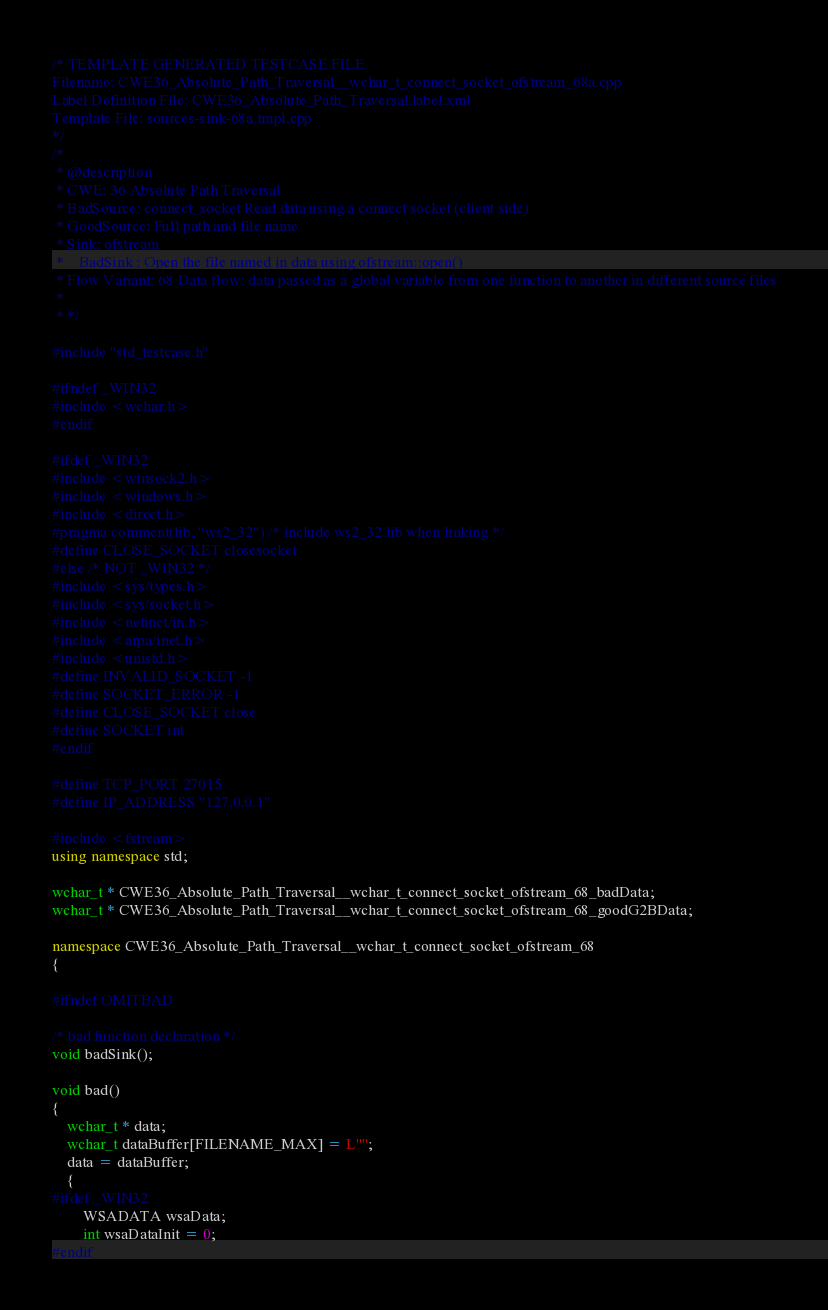Convert code to text. <code><loc_0><loc_0><loc_500><loc_500><_C++_>/* TEMPLATE GENERATED TESTCASE FILE
Filename: CWE36_Absolute_Path_Traversal__wchar_t_connect_socket_ofstream_68a.cpp
Label Definition File: CWE36_Absolute_Path_Traversal.label.xml
Template File: sources-sink-68a.tmpl.cpp
*/
/*
 * @description
 * CWE: 36 Absolute Path Traversal
 * BadSource: connect_socket Read data using a connect socket (client side)
 * GoodSource: Full path and file name
 * Sink: ofstream
 *    BadSink : Open the file named in data using ofstream::open()
 * Flow Variant: 68 Data flow: data passed as a global variable from one function to another in different source files
 *
 * */

#include "std_testcase.h"

#ifndef _WIN32
#include <wchar.h>
#endif

#ifdef _WIN32
#include <winsock2.h>
#include <windows.h>
#include <direct.h>
#pragma comment(lib, "ws2_32") /* include ws2_32.lib when linking */
#define CLOSE_SOCKET closesocket
#else /* NOT _WIN32 */
#include <sys/types.h>
#include <sys/socket.h>
#include <netinet/in.h>
#include <arpa/inet.h>
#include <unistd.h>
#define INVALID_SOCKET -1
#define SOCKET_ERROR -1
#define CLOSE_SOCKET close
#define SOCKET int
#endif

#define TCP_PORT 27015
#define IP_ADDRESS "127.0.0.1"

#include <fstream>
using namespace std;

wchar_t * CWE36_Absolute_Path_Traversal__wchar_t_connect_socket_ofstream_68_badData;
wchar_t * CWE36_Absolute_Path_Traversal__wchar_t_connect_socket_ofstream_68_goodG2BData;

namespace CWE36_Absolute_Path_Traversal__wchar_t_connect_socket_ofstream_68
{

#ifndef OMITBAD

/* bad function declaration */
void badSink();

void bad()
{
    wchar_t * data;
    wchar_t dataBuffer[FILENAME_MAX] = L"";
    data = dataBuffer;
    {
#ifdef _WIN32
        WSADATA wsaData;
        int wsaDataInit = 0;
#endif</code> 